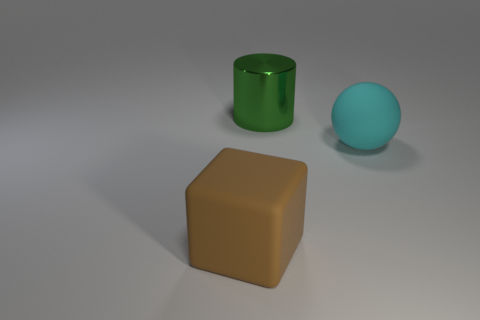How many other objects are there of the same material as the cyan thing?
Your response must be concise. 1. Are there fewer brown matte cubes than red matte cylinders?
Offer a terse response. No. Is the material of the large cyan ball the same as the brown object?
Your response must be concise. Yes. What number of other things are there of the same size as the cyan rubber sphere?
Provide a succinct answer. 2. What color is the large rubber thing that is right of the matte thing in front of the big cyan rubber thing?
Your response must be concise. Cyan. Are there any other cylinders that have the same material as the big green cylinder?
Provide a succinct answer. No. There is a cylinder that is the same size as the matte cube; what is it made of?
Keep it short and to the point. Metal. What is the color of the matte object on the left side of the large matte thing behind the big object that is on the left side of the big green cylinder?
Your answer should be compact. Brown. There is a rubber object on the right side of the block; is its shape the same as the thing behind the large cyan rubber object?
Your response must be concise. No. How many large blocks are there?
Your answer should be very brief. 1. 